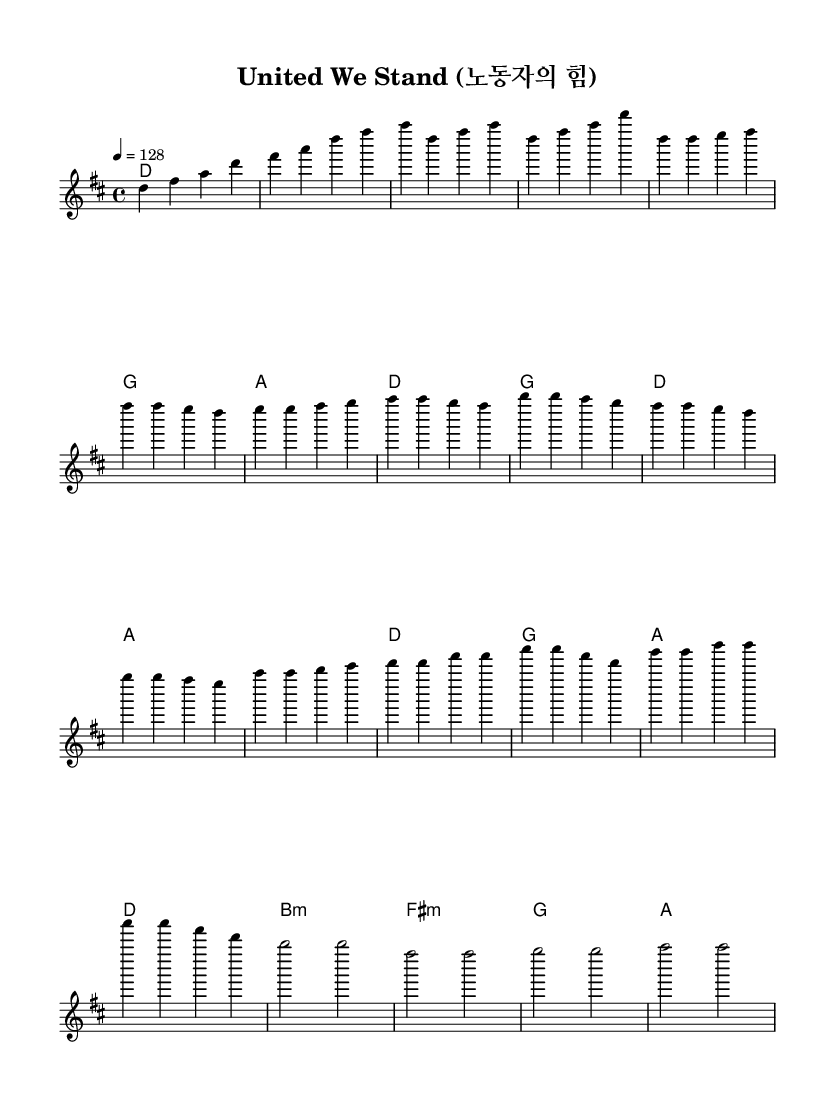What is the key signature of this music? The key signature indicated in the sheet music is D major, which has two sharps (F# and C#).
Answer: D major What is the time signature of this music? The time signature shown in the sheet music is 4/4, meaning there are four beats in each measure.
Answer: 4/4 What is the tempo of this music? The tempo marking specifies a speed of 128 beats per minute, indicated by the "4 = 128" notation.
Answer: 128 How many measures are in the chorus section? By examining the sheet music, the chorus consists of four measures, as indicated by the grouping of notes within the section labeled "Chorus".
Answer: 4 Which section follows the pre-chorus? The next section that comes after the pre-chorus is the chorus, as the structure shows it is placed immediately after.
Answer: Chorus What is the harmonic chord for the bridge section? The harmonic chord progression for the bridge includes B minor, F# minor, G major, and A major, as specified in the harmonies section.
Answer: B minor What thematic message does the title of this K-pop anthem suggest? The title "United We Stand (노동자의 힘)" suggests a theme of solidarity and empowerment for workers, reflecting the importance of worker rights and representation.
Answer: Solidarity 